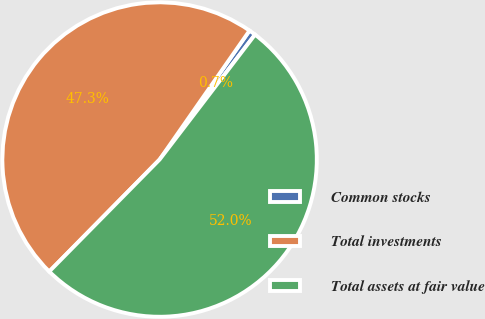Convert chart to OTSL. <chart><loc_0><loc_0><loc_500><loc_500><pie_chart><fcel>Common stocks<fcel>Total investments<fcel>Total assets at fair value<nl><fcel>0.69%<fcel>47.31%<fcel>52.0%<nl></chart> 